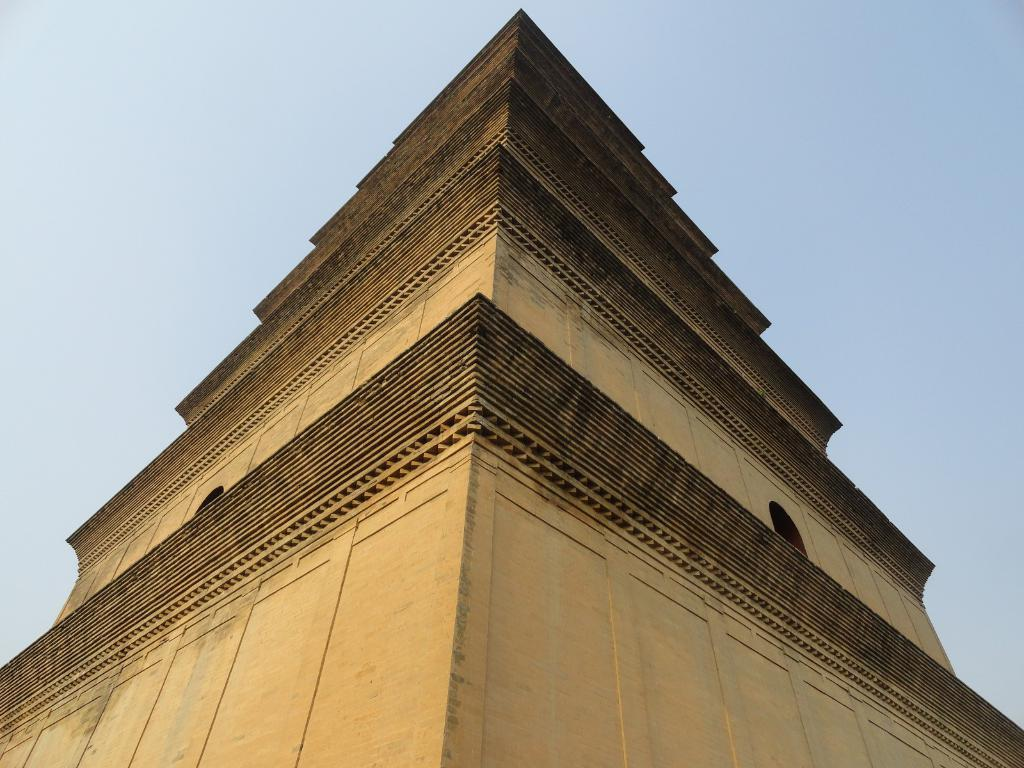What is the main structure visible in the image? There is a building in the image. What colors are used for the building? The building is in cream and black color. What colors are visible in the sky in the image? The sky is in white and blue color. Can you see anyone playing in the image? There is no indication of anyone playing in the image, as it primarily features a building and the colors of the sky. 